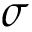Convert formula to latex. <formula><loc_0><loc_0><loc_500><loc_500>\sigma</formula> 